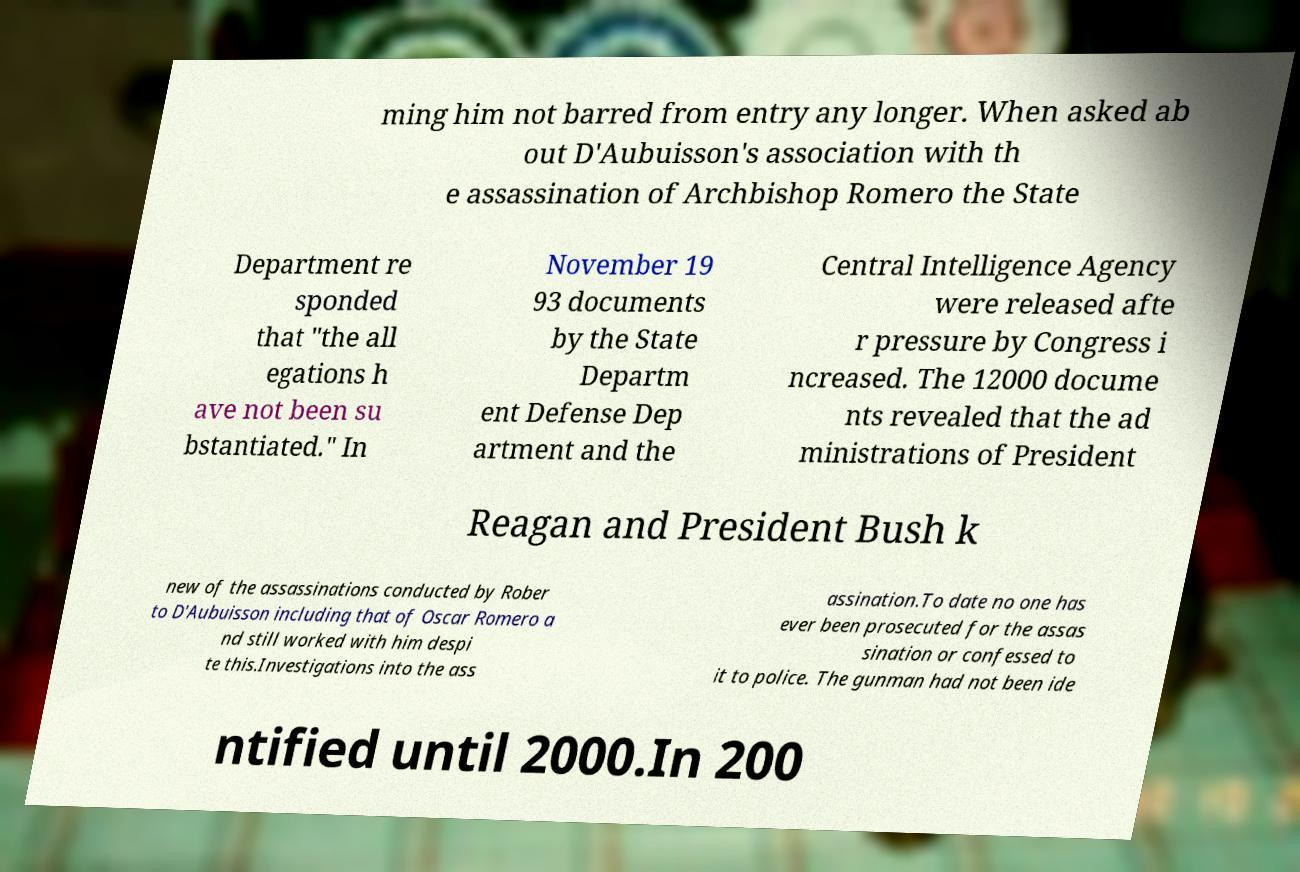Can you accurately transcribe the text from the provided image for me? ming him not barred from entry any longer. When asked ab out D'Aubuisson's association with th e assassination of Archbishop Romero the State Department re sponded that "the all egations h ave not been su bstantiated." In November 19 93 documents by the State Departm ent Defense Dep artment and the Central Intelligence Agency were released afte r pressure by Congress i ncreased. The 12000 docume nts revealed that the ad ministrations of President Reagan and President Bush k new of the assassinations conducted by Rober to D'Aubuisson including that of Oscar Romero a nd still worked with him despi te this.Investigations into the ass assination.To date no one has ever been prosecuted for the assas sination or confessed to it to police. The gunman had not been ide ntified until 2000.In 200 